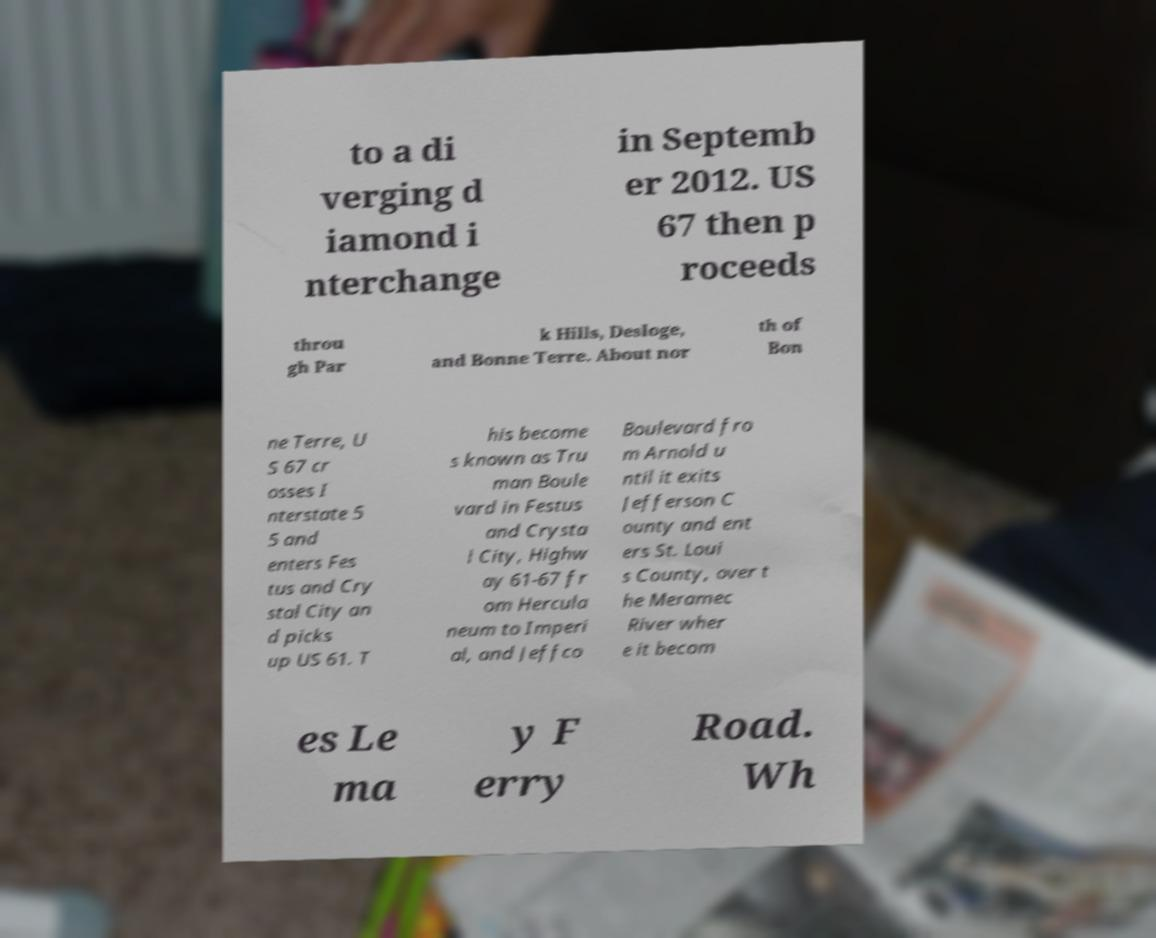For documentation purposes, I need the text within this image transcribed. Could you provide that? to a di verging d iamond i nterchange in Septemb er 2012. US 67 then p roceeds throu gh Par k Hills, Desloge, and Bonne Terre. About nor th of Bon ne Terre, U S 67 cr osses I nterstate 5 5 and enters Fes tus and Cry stal City an d picks up US 61. T his become s known as Tru man Boule vard in Festus and Crysta l City, Highw ay 61-67 fr om Hercula neum to Imperi al, and Jeffco Boulevard fro m Arnold u ntil it exits Jefferson C ounty and ent ers St. Loui s County, over t he Meramec River wher e it becom es Le ma y F erry Road. Wh 